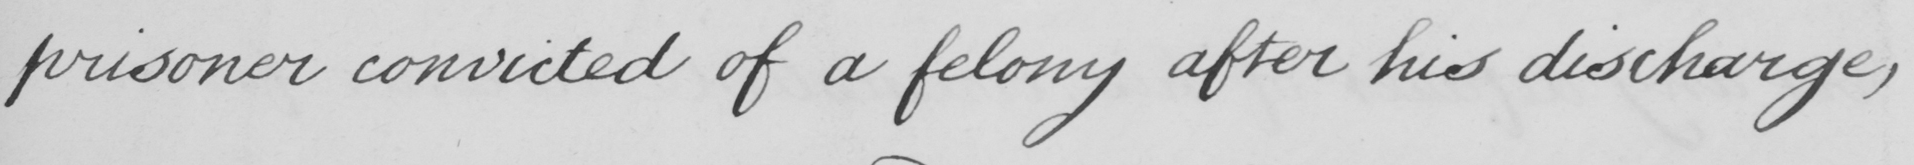What does this handwritten line say? prisoner convicted of a felony after his discharge , 